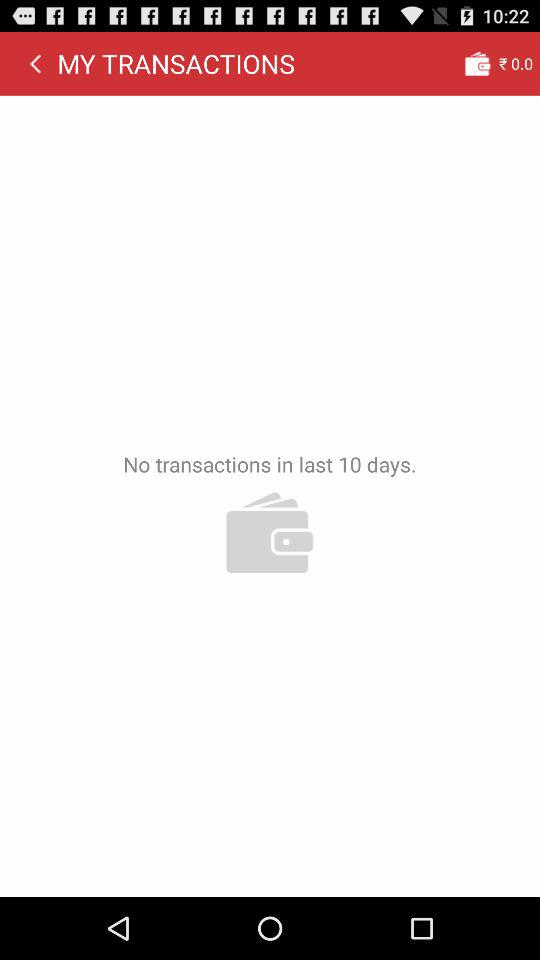How many days have there been no transactions?
Answer the question using a single word or phrase. 10 